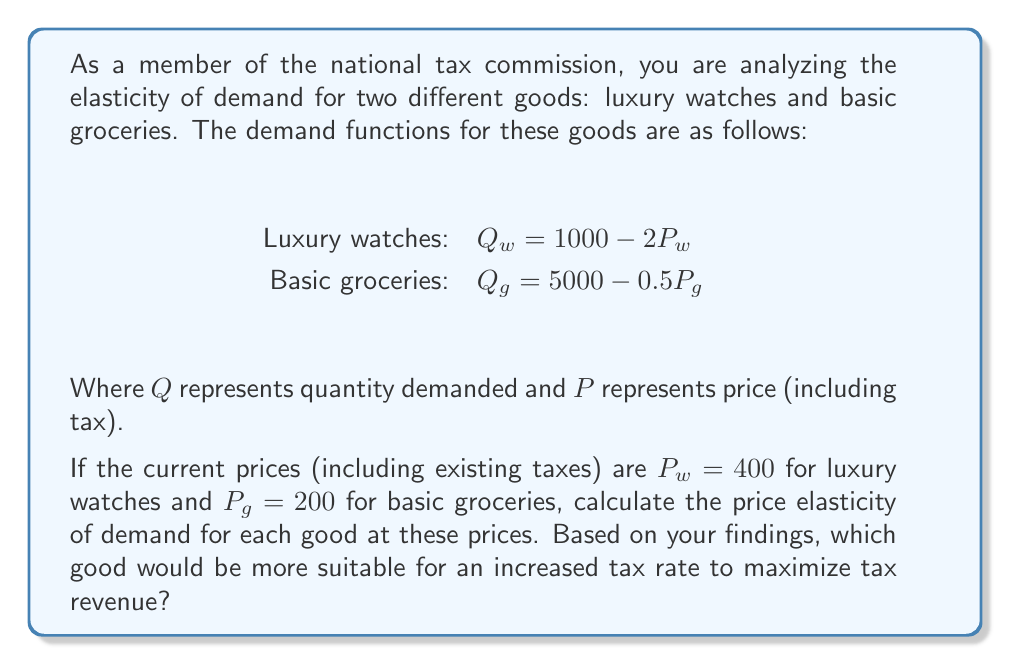Help me with this question. To solve this problem, we'll follow these steps:

1. Calculate the quantity demanded for each good at the current prices.
2. Find the price elasticity of demand for each good using the point elasticity formula.
3. Interpret the results and determine which good is more suitable for increased taxation.

Step 1: Calculate quantity demanded

For luxury watches:
$Q_w = 1000 - 2P_w = 1000 - 2(400) = 200$

For basic groceries:
$Q_g = 5000 - 0.5P_g = 5000 - 0.5(200) = 4900$

Step 2: Calculate price elasticity of demand

The point elasticity formula is:

$$ E_p = \left|\frac{\Delta Q}{\Delta P} \cdot \frac{P}{Q}\right| = \left|\frac{dQ}{dP} \cdot \frac{P}{Q}\right| $$

For luxury watches:
$$ E_{p,w} = \left|-2 \cdot \frac{400}{200}\right| = 4 $$

For basic groceries:
$$ E_{p,g} = \left|-0.5 \cdot \frac{200}{4900}\right| = 0.0204 $$

Step 3: Interpret results

Luxury watches have an elastic demand ($E_{p,w} > 1$), while basic groceries have an inelastic demand ($E_{p,g} < 1$).

In general, goods with inelastic demand are more suitable for increased taxation to maximize tax revenue. This is because an increase in price (due to higher taxes) will result in a proportionally smaller decrease in quantity demanded, potentially leading to higher overall tax revenue.

Therefore, based on the elasticity calculations, basic groceries would be more suitable for an increased tax rate to maximize tax revenue. However, it's important to note that taxing necessities like basic groceries may have negative social implications and disproportionately affect lower-income individuals.
Answer: The price elasticity of demand for luxury watches is 4 (elastic), and for basic groceries is 0.0204 (inelastic). Based on these elasticities, basic groceries would be more suitable for an increased tax rate to maximize tax revenue, though social implications should be considered. 